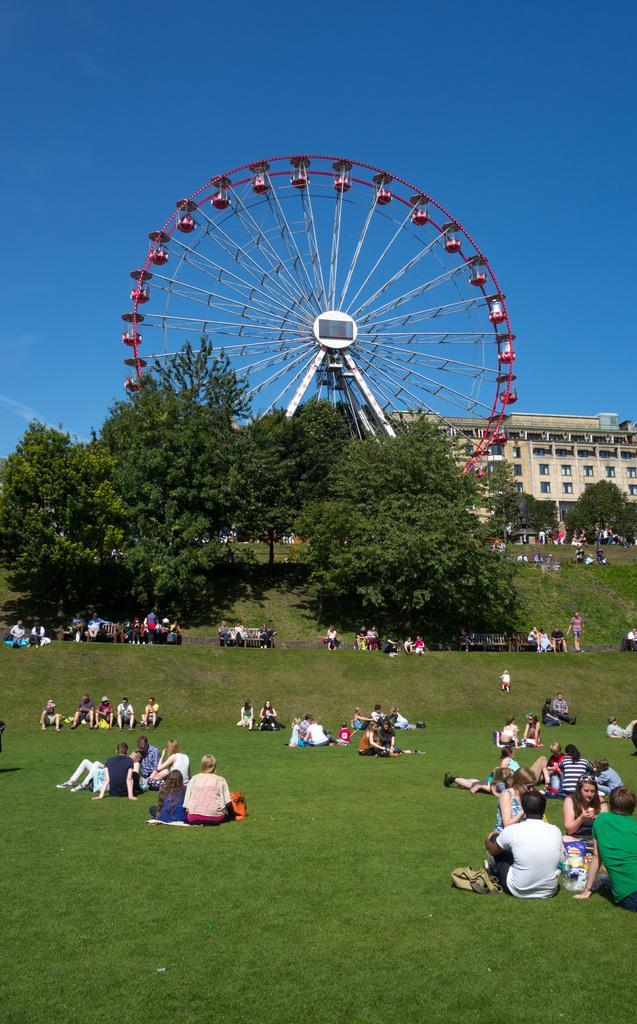How would you summarize this image in a sentence or two? In this image there are a few people sitting on the grass and on the benches, behind them there are trees, a giant wheel and a building. 